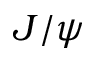<formula> <loc_0><loc_0><loc_500><loc_500>J / \psi</formula> 